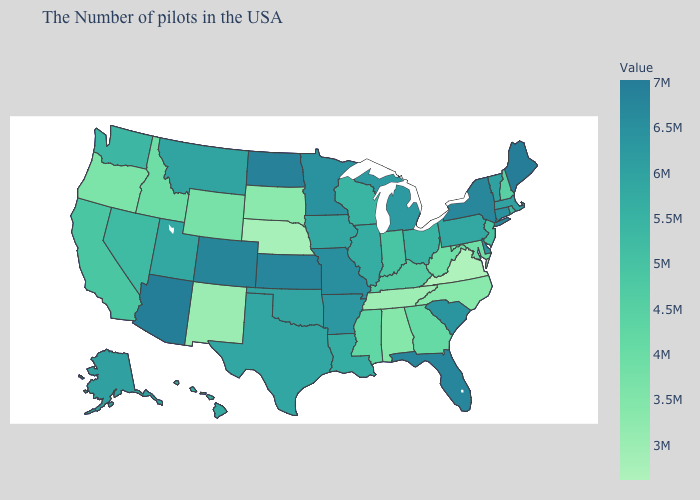Among the states that border Tennessee , which have the lowest value?
Short answer required. Virginia. Among the states that border Minnesota , does Wisconsin have the highest value?
Short answer required. No. Does Pennsylvania have a lower value than Arizona?
Short answer required. Yes. Among the states that border Idaho , does Nevada have the lowest value?
Short answer required. No. Does New Mexico have the lowest value in the West?
Write a very short answer. Yes. Among the states that border Idaho , which have the highest value?
Write a very short answer. Montana. 